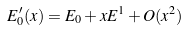Convert formula to latex. <formula><loc_0><loc_0><loc_500><loc_500>E ^ { \prime } _ { 0 } ( x ) = E _ { 0 } + x E ^ { 1 } + O ( x ^ { 2 } )</formula> 